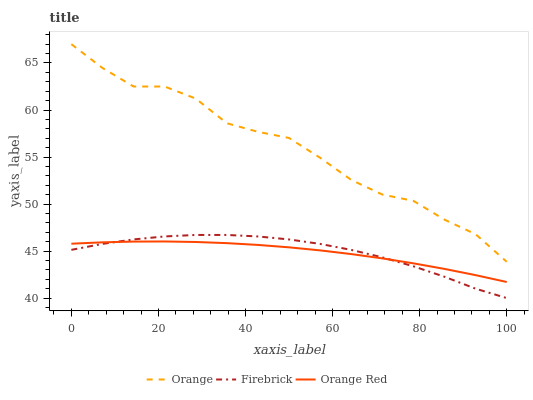Does Orange Red have the minimum area under the curve?
Answer yes or no. Yes. Does Orange have the maximum area under the curve?
Answer yes or no. Yes. Does Firebrick have the minimum area under the curve?
Answer yes or no. No. Does Firebrick have the maximum area under the curve?
Answer yes or no. No. Is Orange Red the smoothest?
Answer yes or no. Yes. Is Orange the roughest?
Answer yes or no. Yes. Is Firebrick the smoothest?
Answer yes or no. No. Is Firebrick the roughest?
Answer yes or no. No. Does Firebrick have the lowest value?
Answer yes or no. Yes. Does Orange Red have the lowest value?
Answer yes or no. No. Does Orange have the highest value?
Answer yes or no. Yes. Does Firebrick have the highest value?
Answer yes or no. No. Is Orange Red less than Orange?
Answer yes or no. Yes. Is Orange greater than Orange Red?
Answer yes or no. Yes. Does Orange Red intersect Firebrick?
Answer yes or no. Yes. Is Orange Red less than Firebrick?
Answer yes or no. No. Is Orange Red greater than Firebrick?
Answer yes or no. No. Does Orange Red intersect Orange?
Answer yes or no. No. 